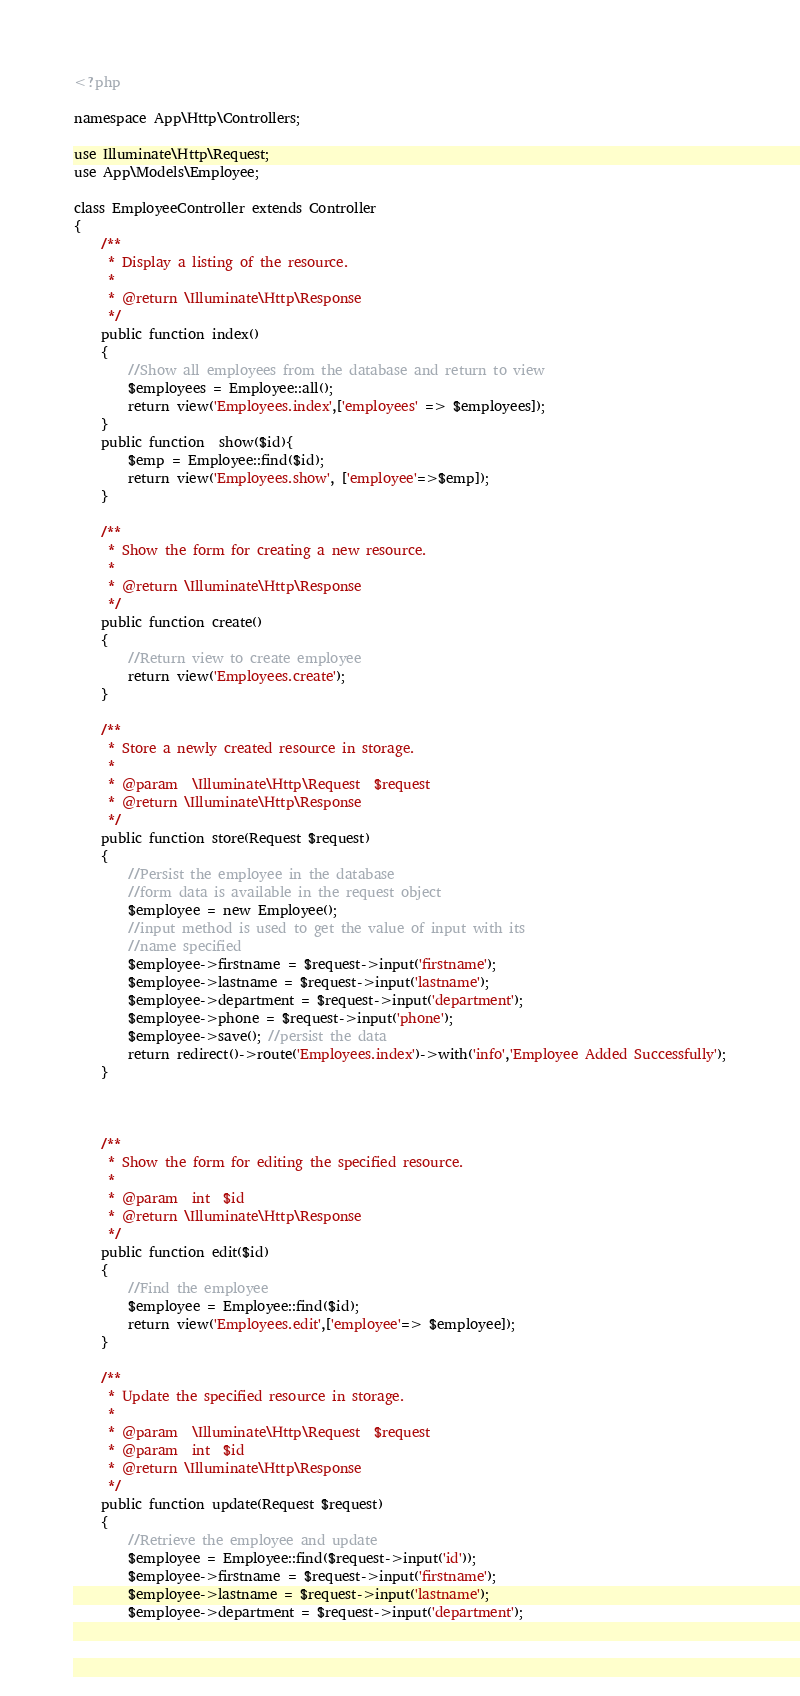Convert code to text. <code><loc_0><loc_0><loc_500><loc_500><_PHP_><?php

namespace App\Http\Controllers;

use Illuminate\Http\Request;
use App\Models\Employee;

class EmployeeController extends Controller
{
    /**
     * Display a listing of the resource.
     *
     * @return \Illuminate\Http\Response
     */
    public function index()
    {
        //Show all employees from the database and return to view
        $employees = Employee::all();
        return view('Employees.index',['employees' => $employees]);
    }
    public function  show($id){
        $emp = Employee::find($id);
        return view('Employees.show', ['employee'=>$emp]);
    }

    /**
     * Show the form for creating a new resource.
     *
     * @return \Illuminate\Http\Response
     */
    public function create()
    {
        //Return view to create employee
        return view('Employees.create');
    }

    /**
     * Store a newly created resource in storage.
     *
     * @param  \Illuminate\Http\Request  $request
     * @return \Illuminate\Http\Response
     */
    public function store(Request $request)
    {
        //Persist the employee in the database
        //form data is available in the request object
        $employee = new Employee();
        //input method is used to get the value of input with its
        //name specified
        $employee->firstname = $request->input('firstname');
        $employee->lastname = $request->input('lastname');
        $employee->department = $request->input('department');
        $employee->phone = $request->input('phone');
        $employee->save(); //persist the data
        return redirect()->route('Employees.index')->with('info','Employee Added Successfully');
    }



    /**
     * Show the form for editing the specified resource.
     *
     * @param  int  $id
     * @return \Illuminate\Http\Response
     */
    public function edit($id)
    {
        //Find the employee
        $employee = Employee::find($id);
        return view('Employees.edit',['employee'=> $employee]);
    }

    /**
     * Update the specified resource in storage.
     *
     * @param  \Illuminate\Http\Request  $request
     * @param  int  $id
     * @return \Illuminate\Http\Response
     */
    public function update(Request $request)
    {
        //Retrieve the employee and update
        $employee = Employee::find($request->input('id'));
        $employee->firstname = $request->input('firstname');
        $employee->lastname = $request->input('lastname');
        $employee->department = $request->input('department');</code> 